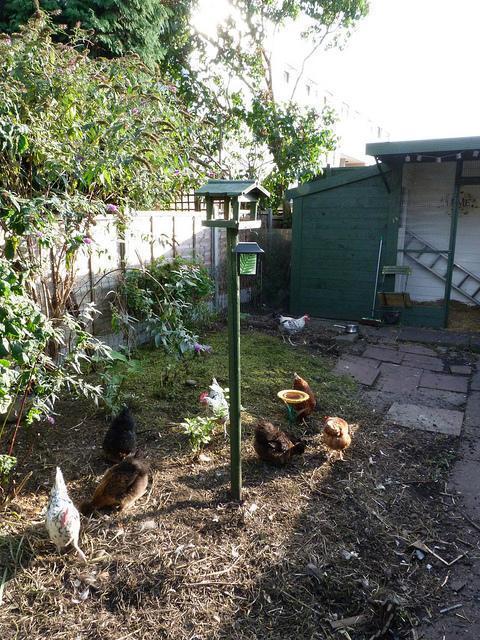How many spotted white chickens are there?
Answer the question by selecting the correct answer among the 4 following choices and explain your choice with a short sentence. The answer should be formatted with the following format: `Answer: choice
Rationale: rationale.`
Options: Three, one, two, four. Answer: three.
Rationale: There is one by the green part of the house, one by the grass and one in the dirt. 